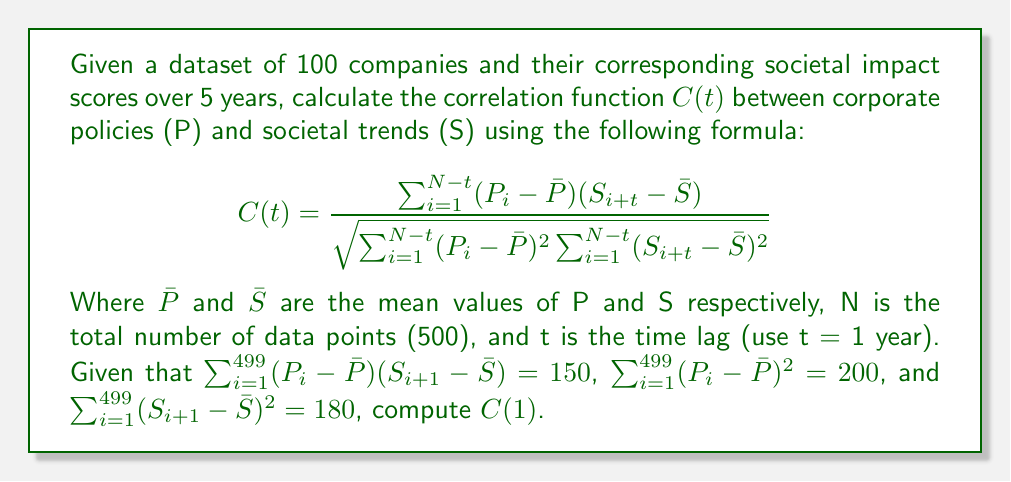What is the answer to this math problem? To calculate the correlation function $C(t)$ for t = 1 year, we'll use the given formula and the provided information:

1. We have:
   $\sum_{i=1}^{499} (P_i - \bar{P})(S_{i+1} - \bar{S}) = 150$
   $\sum_{i=1}^{499} (P_i - \bar{P})^2 = 200$
   $\sum_{i=1}^{499} (S_{i+1} - \bar{S})^2 = 180$

2. Substituting these values into the correlation function formula:

   $$C(1) = \frac{150}{\sqrt{200 \cdot 180}}$$

3. Simplify the denominator:
   $$C(1) = \frac{150}{\sqrt{36000}}$$

4. Calculate the square root:
   $$C(1) = \frac{150}{189.7366}$$

5. Divide:
   $$C(1) \approx 0.7905$$

The correlation function $C(1)$ is approximately 0.7905, indicating a strong positive correlation between corporate policies and societal trends with a one-year lag.
Answer: $C(1) \approx 0.7905$ 